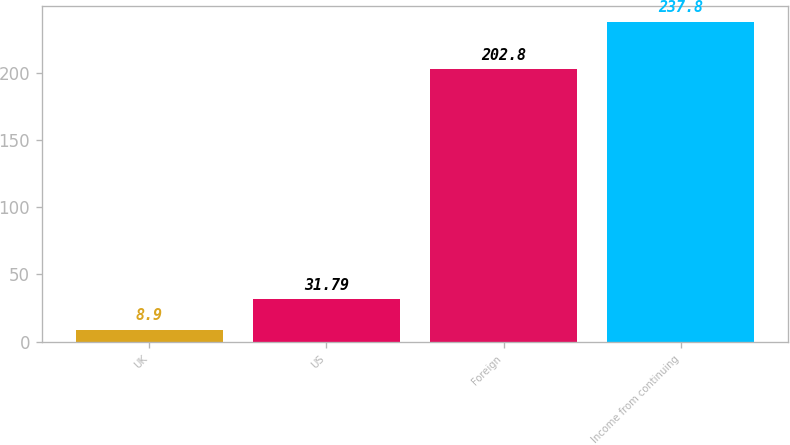Convert chart to OTSL. <chart><loc_0><loc_0><loc_500><loc_500><bar_chart><fcel>UK<fcel>US<fcel>Foreign<fcel>Income from continuing<nl><fcel>8.9<fcel>31.79<fcel>202.8<fcel>237.8<nl></chart> 